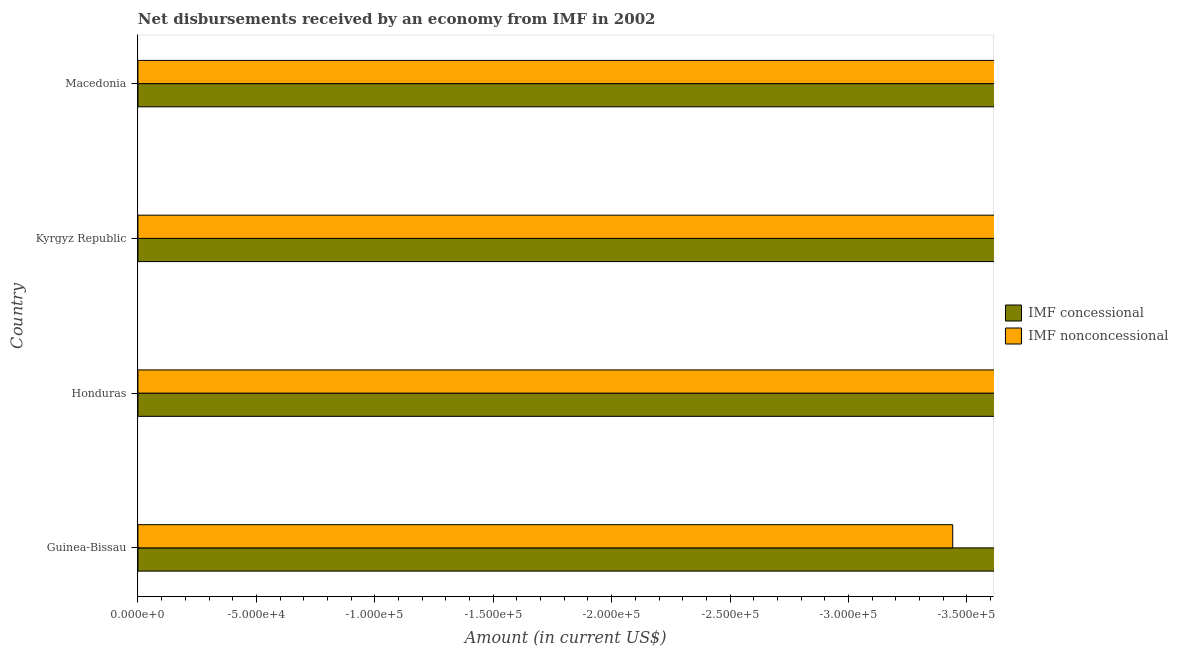How many different coloured bars are there?
Provide a short and direct response. 0. Are the number of bars on each tick of the Y-axis equal?
Keep it short and to the point. Yes. How many bars are there on the 4th tick from the top?
Provide a succinct answer. 0. How many bars are there on the 2nd tick from the bottom?
Offer a terse response. 0. What is the label of the 3rd group of bars from the top?
Give a very brief answer. Honduras. What is the net concessional disbursements from imf in Kyrgyz Republic?
Provide a succinct answer. 0. Across all countries, what is the minimum net non concessional disbursements from imf?
Offer a very short reply. 0. In how many countries, is the net non concessional disbursements from imf greater than -100000 US$?
Provide a succinct answer. 0. Are all the bars in the graph horizontal?
Your response must be concise. Yes. What is the title of the graph?
Provide a short and direct response. Net disbursements received by an economy from IMF in 2002. What is the label or title of the X-axis?
Your response must be concise. Amount (in current US$). What is the Amount (in current US$) in IMF concessional in Honduras?
Make the answer very short. 0. What is the Amount (in current US$) in IMF nonconcessional in Honduras?
Offer a very short reply. 0. What is the Amount (in current US$) in IMF concessional in Kyrgyz Republic?
Your response must be concise. 0. What is the Amount (in current US$) in IMF nonconcessional in Kyrgyz Republic?
Ensure brevity in your answer.  0. What is the total Amount (in current US$) in IMF concessional in the graph?
Keep it short and to the point. 0. What is the total Amount (in current US$) of IMF nonconcessional in the graph?
Your response must be concise. 0. 